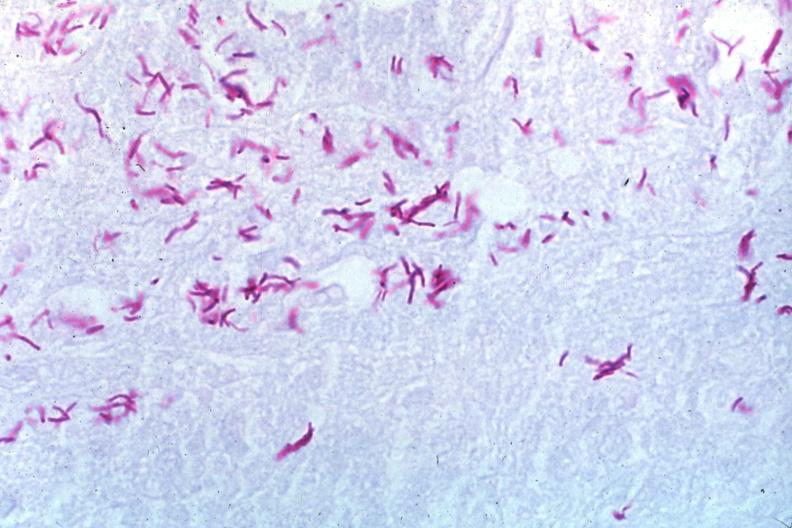what is present?
Answer the question using a single word or phrase. Lymph node 